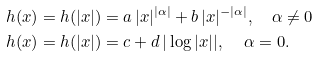<formula> <loc_0><loc_0><loc_500><loc_500>h ( x ) = h ( | x | ) & = a \, | x | ^ { | \alpha | } + b \, | x | ^ { - | \alpha | } , \quad \alpha \neq 0 \\ h ( x ) = h ( | x | ) & = c + d \, | \log | x | | , \quad \, \alpha = 0 .</formula> 